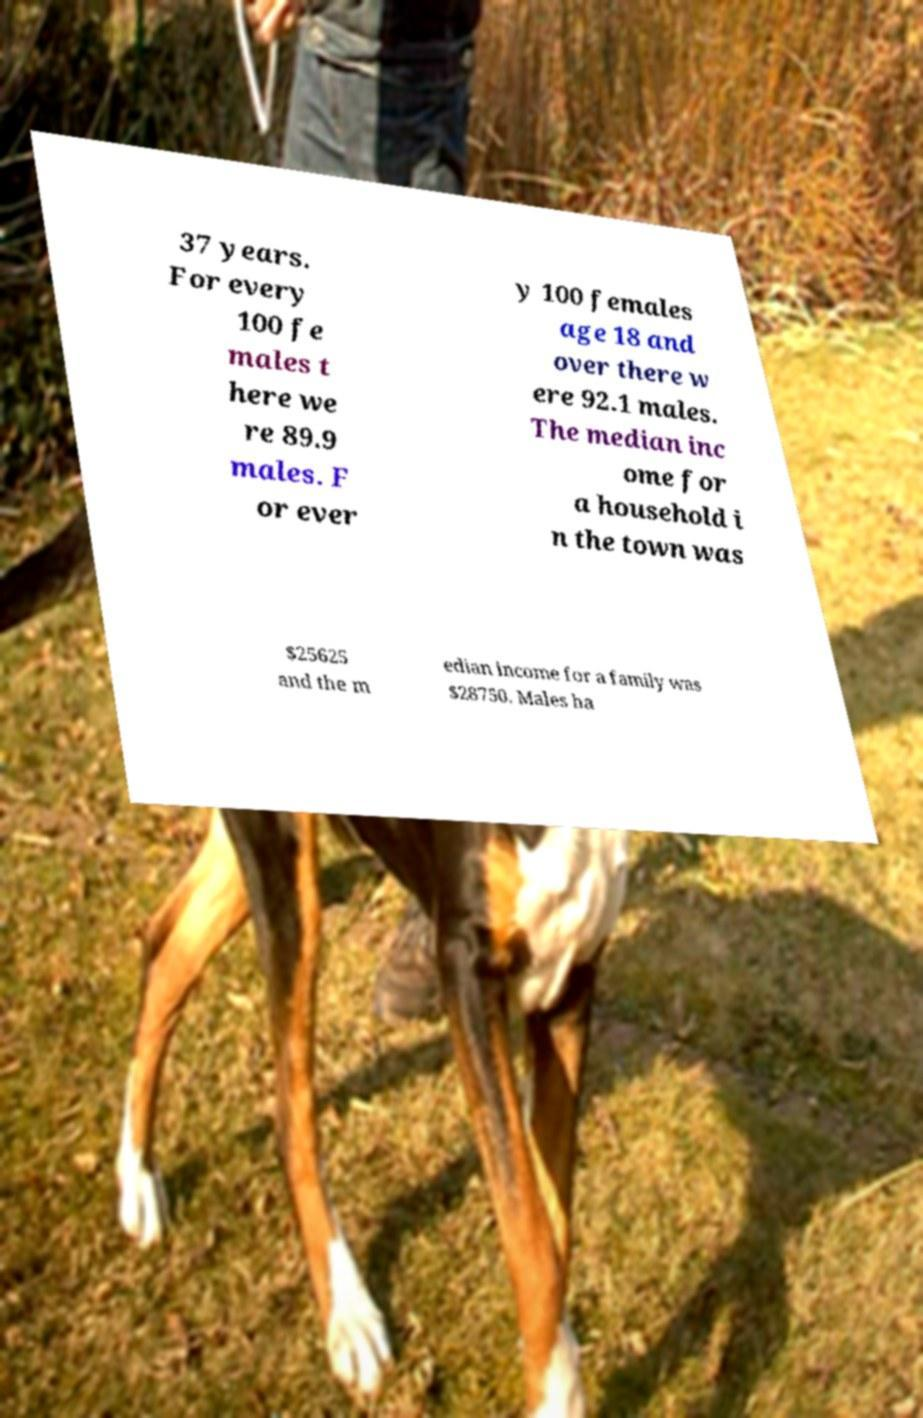Can you accurately transcribe the text from the provided image for me? 37 years. For every 100 fe males t here we re 89.9 males. F or ever y 100 females age 18 and over there w ere 92.1 males. The median inc ome for a household i n the town was $25625 and the m edian income for a family was $28750. Males ha 